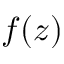<formula> <loc_0><loc_0><loc_500><loc_500>f ( z )</formula> 